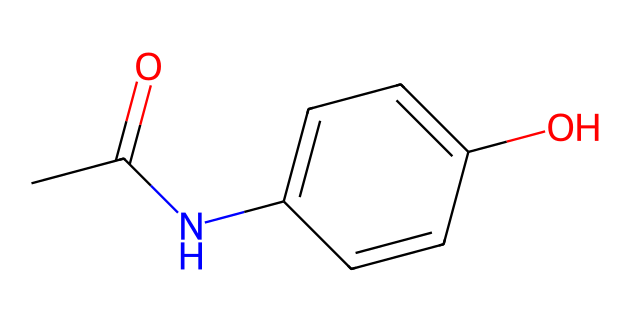What is the molecular formula of acetaminophen? By analyzing the SMILES code, we identify that it contains 8 carbon atoms (C), 9 hydrogen atoms (H), 1 nitrogen atom (N), and 1 oxygen atom (O). Therefore, the molecular formula can be written as C8H9NO2.
Answer: C8H9NO2 How many rings are present in the chemical structure? The SMILES code indicates the presence of a cyclic structure indicated by 'C1', which means there is one ring in the molecule.
Answer: 1 What functional group is primarily responsible for the pain-relieving property? The presence of the amide group (-NHC(=O)-) indicated in the SMILES structure contributes to the pain-relieving properties of acetaminophen.
Answer: amide Which atom signifies that this molecule can form hydrogen bonds? The presence of the nitrogen (N) in the amide group and the hydroxyl group (-OH) allows for hydrogen bonding. Therefore, both these atoms are significant.
Answer: nitrogen and oxygen How many double bonds are present in acetaminophen? By looking at the SMILES, there are two double bonds: one in the carbonyl group (C=O) and one in the aromatic ring (C=C).
Answer: 2 What is the primary aromatic component in the molecule? The presence of the benzene ring as part of the cyclic structure indicates that the primary aromatic component is the phenyl group, which is part of C1=CC=C(C=C1).
Answer: phenyl group What is the overall charge of the acetaminophen molecule? The molecular structure of acetaminophen does not contain any ions or charged groups; thus, it has no overall charge. It is neutral.
Answer: neutral 